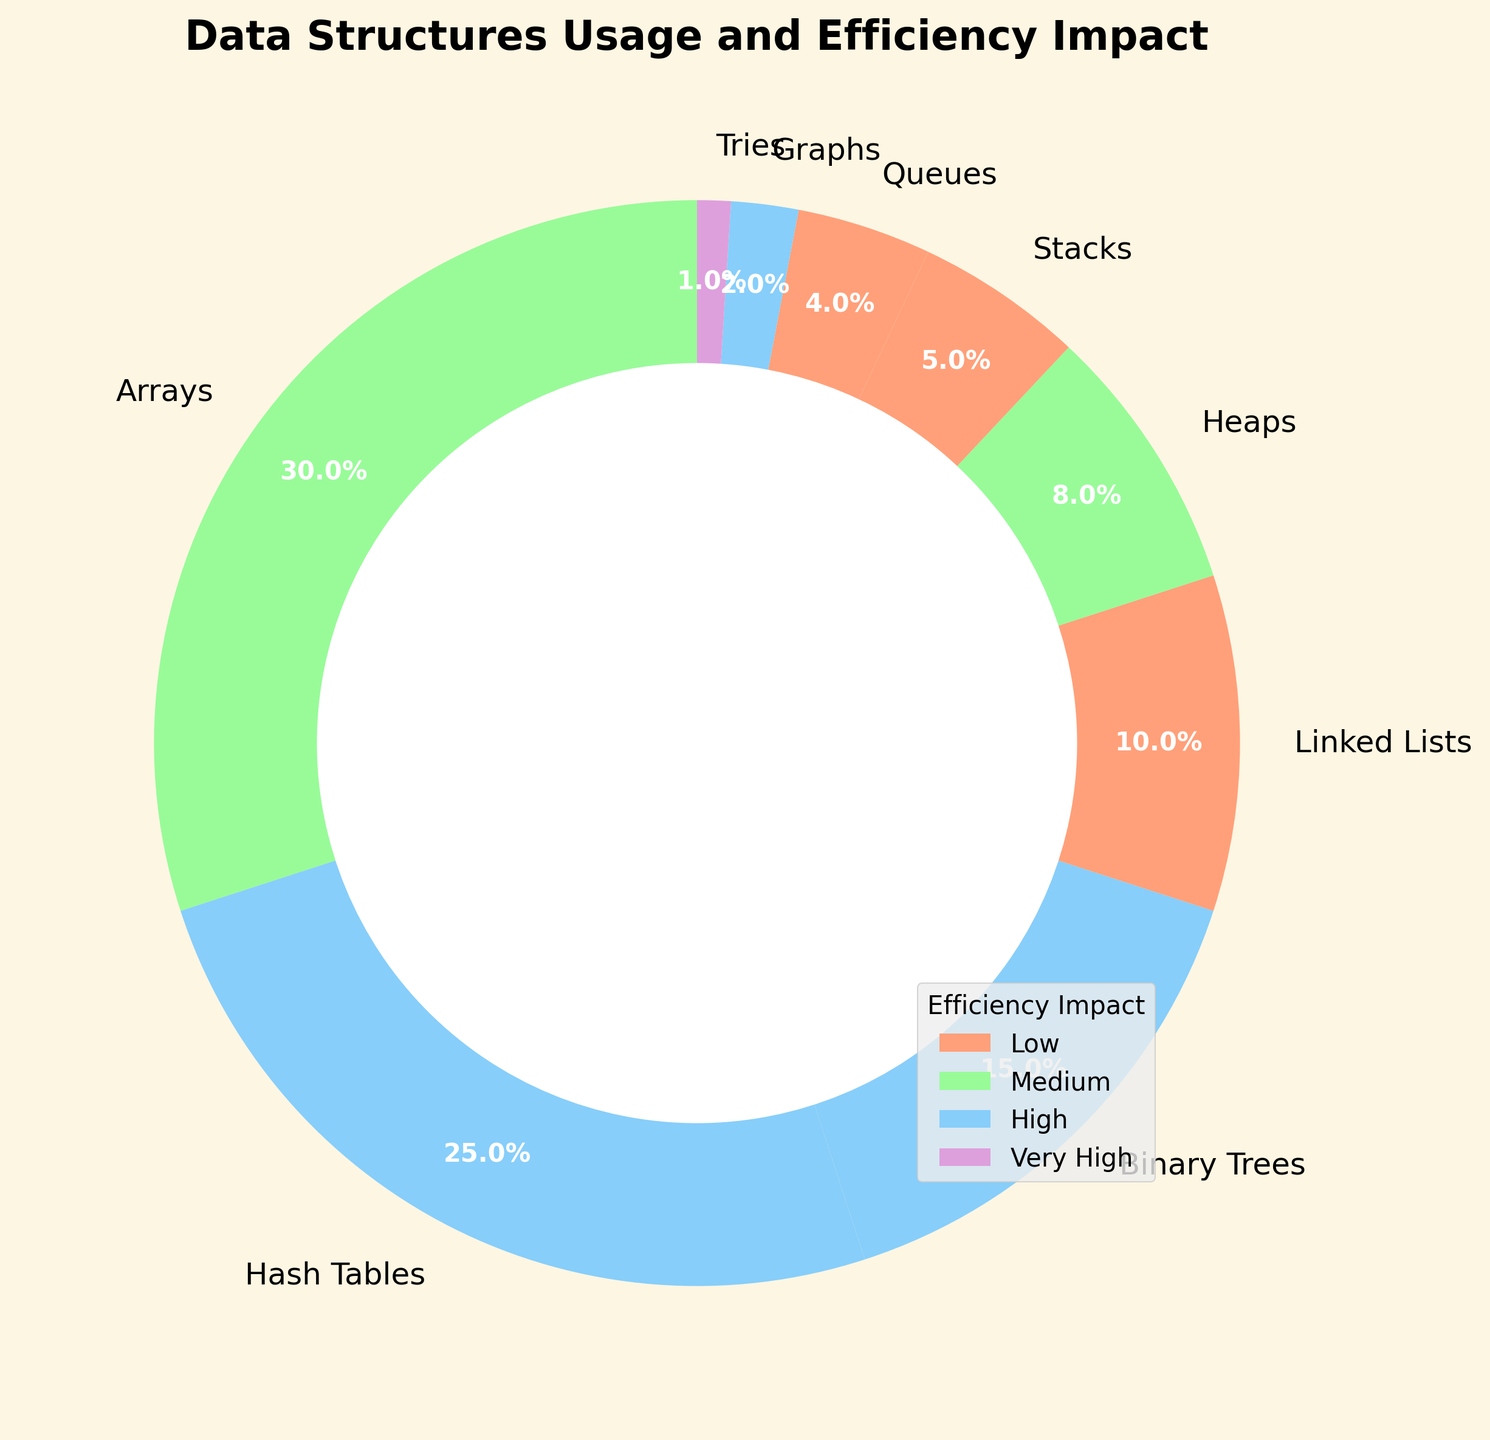How much percentage of the data structures used have a high impact on efficiency? Add the percentages of data structures with a high impact on efficiency. These are Hash Tables (25%), Binary Trees (15%), and Graphs (2%), which sum up to 25% + 15% + 2%.
Answer: 42% Which data structure category has the highest efficiency impact and the lowest percentage used? Identify the data structure with the highest efficiency impact and check its corresponding usage percentage. Tries have a "Very High" impact but only 1% usage.
Answer: Tries What is the combined usage percentage of all data structures with low impact on efficiency? Add the percentages of data structures with low impact on efficiency. These are Linked Lists (10%), Stacks (5%), and Queues (4%), which sum up to 10% + 5% + 4%.
Answer: 19% Among data structures with medium impact on efficiency, which one is used the most? Compare the usage percentages of data structures with a medium impact. Arrays are used (30%), and Heaps (8%) are compared.
Answer: Arrays How does the usage of Hash Tables compare to the combined usage of Stacks and Queues? Hash Tables usage is 25%. The combined usage of Stacks and Queues is 5% + 4%. 25% - 9% gives the difference.
Answer: 16% more What is the ratio of the usage of Arrays to Heaps? Divide the usage percentage of Arrays by the usage percentage of Heaps. Arrays (30%) / Heaps (8%).
Answer: 3.75:1 What is the total percentage of data structures that have less than 10% usage? Add the percentages of data structures that have less than 10% usage. These are Heaps (8%), Stacks (5%), Queues (4%), Graphs (2%), and Tries (1%), summing up to 8% + 5% + 4% + 2% + 1%.
Answer: 20% Which data structure has the second-highest impact on efficiency and also has the second-highest usage? First, identify the data structure with "High" impact and then find the one with the second-highest percentage. Binary Trees have a high efficiency impact and 15% usage, which is the second highest after Hash Tables.
Answer: Binary Trees How many data structures have a "Very High" or "High" impact on efficiency? Count the data structures with "Very High" and "High" impacts. Tries (Very High), Hash Tables, Binary Trees, and Graphs (High) are counted.
Answer: 4 